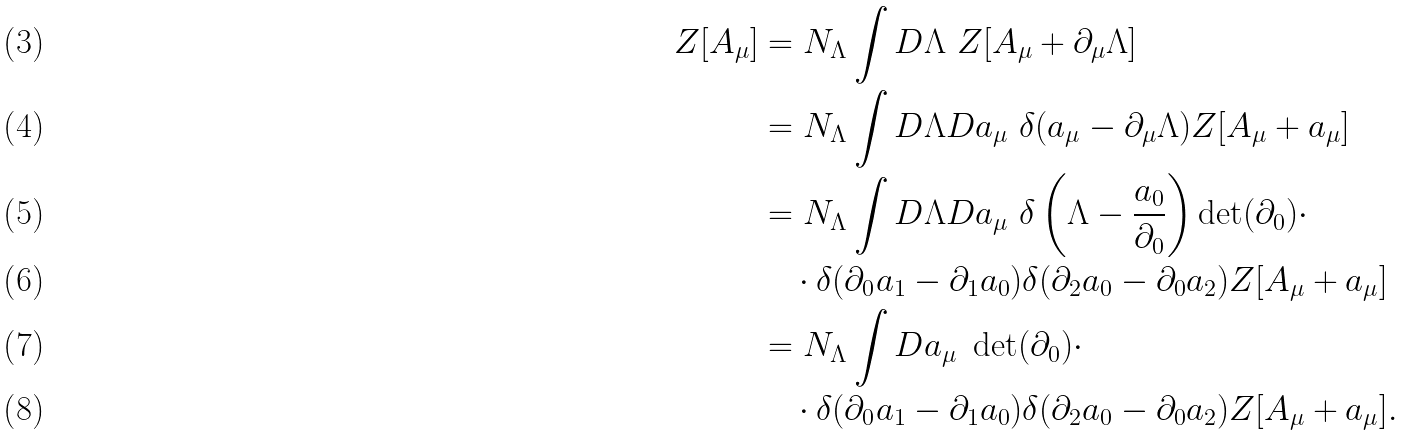Convert formula to latex. <formula><loc_0><loc_0><loc_500><loc_500>Z [ A _ { \mu } ] & = N _ { \Lambda } \int D \Lambda \ Z [ A _ { \mu } + \partial _ { \mu } \Lambda ] \\ & = N _ { \Lambda } \int D \Lambda D a _ { \mu } \ \delta ( a _ { \mu } - \partial _ { \mu } \Lambda ) Z [ A _ { \mu } + a _ { \mu } ] \\ & = N _ { \Lambda } \int D \Lambda D a _ { \mu } \ \delta \left ( \Lambda - \frac { a _ { 0 } } { \partial _ { 0 } } \right ) \det ( \partial _ { 0 } ) \cdot \\ & \quad \cdot \delta ( \partial _ { 0 } a _ { 1 } - \partial _ { 1 } a _ { 0 } ) \delta ( \partial _ { 2 } a _ { 0 } - \partial _ { 0 } a _ { 2 } ) Z [ A _ { \mu } + a _ { \mu } ] \\ & = N _ { \Lambda } \int D a _ { \mu } \ \det ( \partial _ { 0 } ) \cdot \\ & \quad \cdot \delta ( \partial _ { 0 } a _ { 1 } - \partial _ { 1 } a _ { 0 } ) \delta ( \partial _ { 2 } a _ { 0 } - \partial _ { 0 } a _ { 2 } ) Z [ A _ { \mu } + a _ { \mu } ] .</formula> 